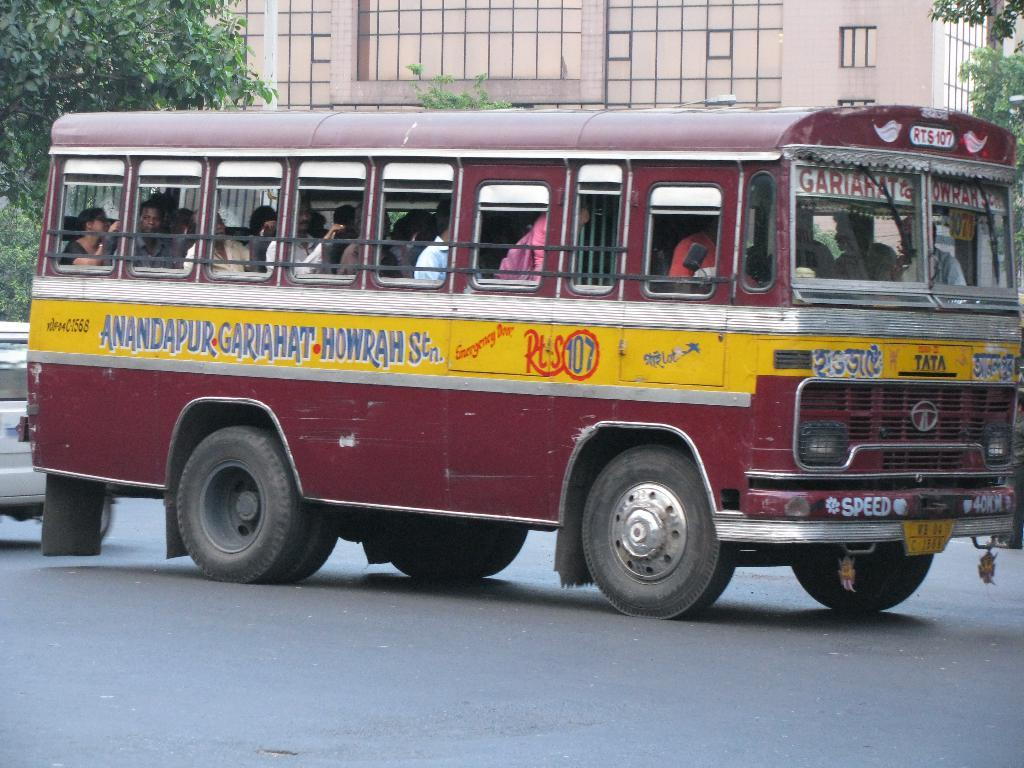<image>
Summarize the visual content of the image. A run down looking red and yellow bus operates on route 107. 